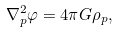Convert formula to latex. <formula><loc_0><loc_0><loc_500><loc_500>\nabla _ { p } ^ { 2 } \varphi = 4 \pi G \rho _ { p } ,</formula> 